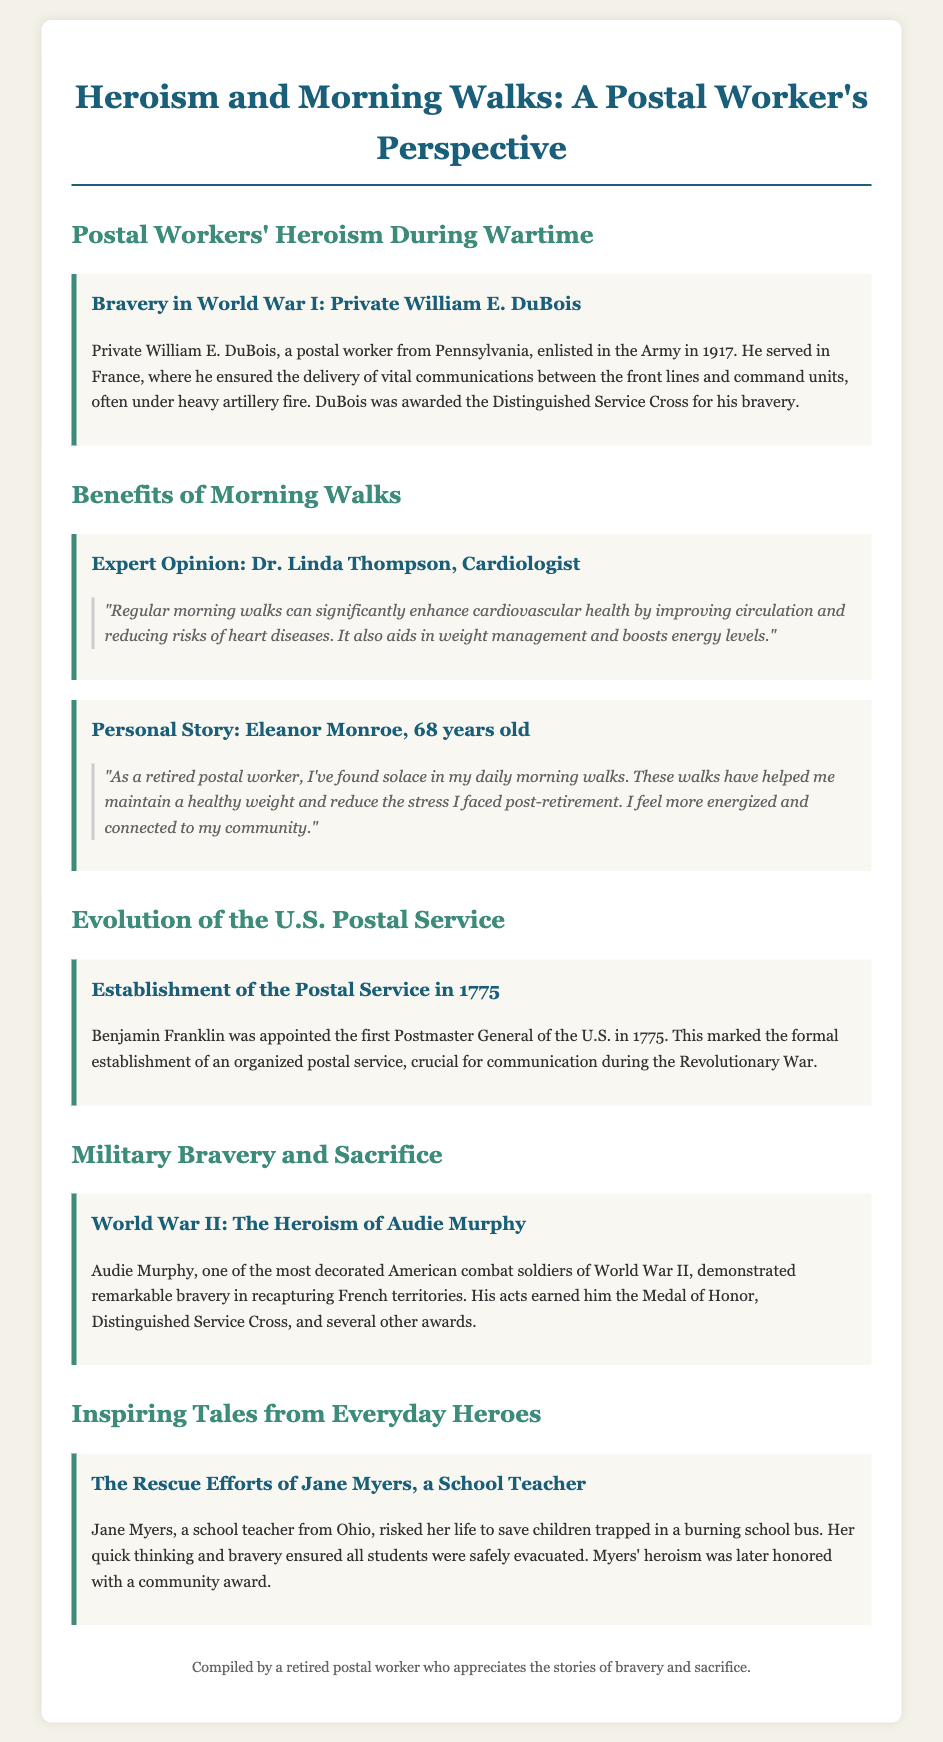What is the name of the postal worker awarded the Distinguished Service Cross? Private William E. DuBois was awarded the Distinguished Service Cross for his bravery during World War I.
Answer: Private William E. DuBois Who shared an expert opinion about the benefits of morning walks? Dr. Linda Thompson, a cardiologist, provided expert insights on the health benefits of morning walks.
Answer: Dr. Linda Thompson What year was the U.S. Postal Service established? The document states that the formal establishment of the U.S. Postal Service occurred in 1775.
Answer: 1775 What heroic act did Jane Myers perform? Jane Myers risked her life to save children trapped in a burning school bus, showcasing her bravery.
Answer: Saved children from a burning school bus Which war did Audie Murphy serve in? Audie Murphy is recognized for his acts during World War II, where he earned multiple prestigious awards for his bravery.
Answer: World War II What is one reported health benefit of daily morning walks? One significant benefit mentioned is the improvement of cardiovascular health through regular morning walks.
Answer: Improved cardiovascular health In what war did Benjamin Franklin play a crucial role? Benjamin Franklin was crucial for communication during the Revolutionary War, linked to the establishment of the U.S. Postal Service.
Answer: Revolutionary War How did Eleanor Monroe describe her experience with morning walks? Eleanor Monroe described her daily morning walks as a source of solace, helping her maintain weight and reducing stress.
Answer: Source of solace 